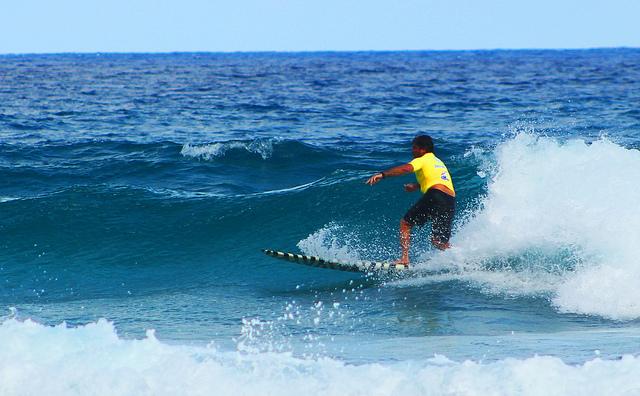Is there a mountain in the background?
Quick response, please. No. What color shirt is the man wearing?
Answer briefly. Yellow. What is this man doing?
Answer briefly. Surfing. Is it  turbulent water?
Concise answer only. Yes. 